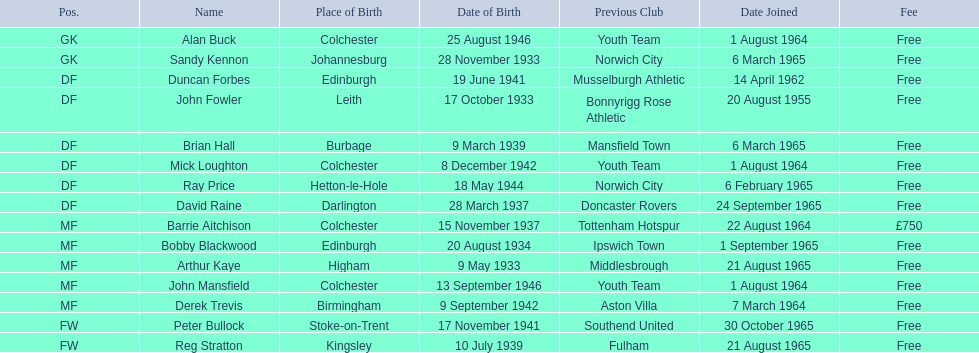In the 1965-66 season, when did alan buck become a member of colchester united f.c.? 1 August 1964. When did the final player join the team during that season? Peter Bullock. On what date did the first player join? 20 August 1955. 